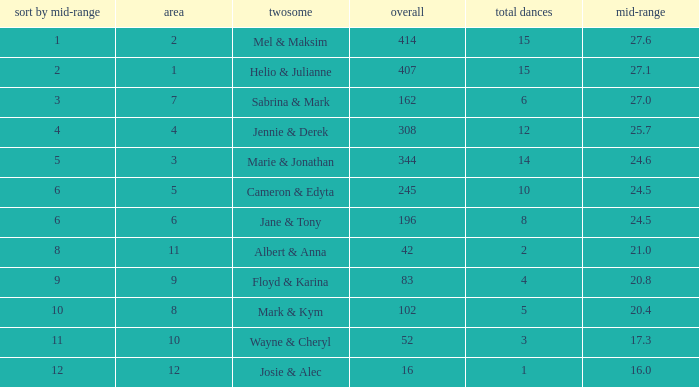What is the average when the rank by average is more than 12? None. 